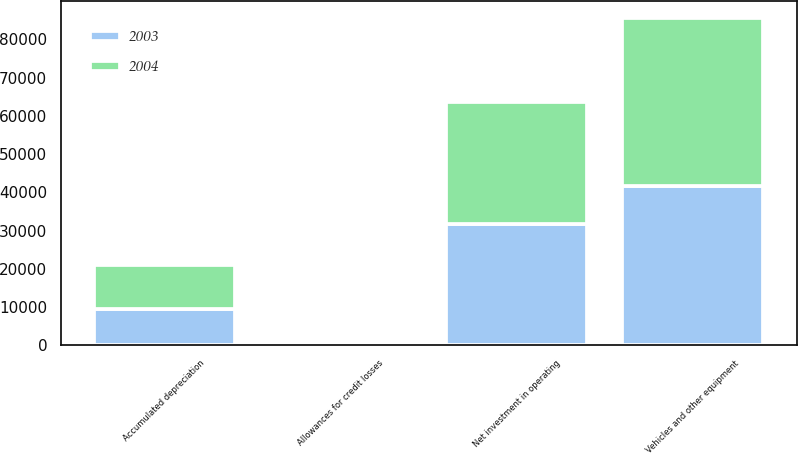Convert chart to OTSL. <chart><loc_0><loc_0><loc_500><loc_500><stacked_bar_chart><ecel><fcel>Vehicles and other equipment<fcel>Accumulated depreciation<fcel>Allowances for credit losses<fcel>Net investment in operating<nl><fcel>2003<fcel>41545<fcel>9477<fcel>305<fcel>31763<nl><fcel>2004<fcel>44098<fcel>11615<fcel>624<fcel>31859<nl></chart> 